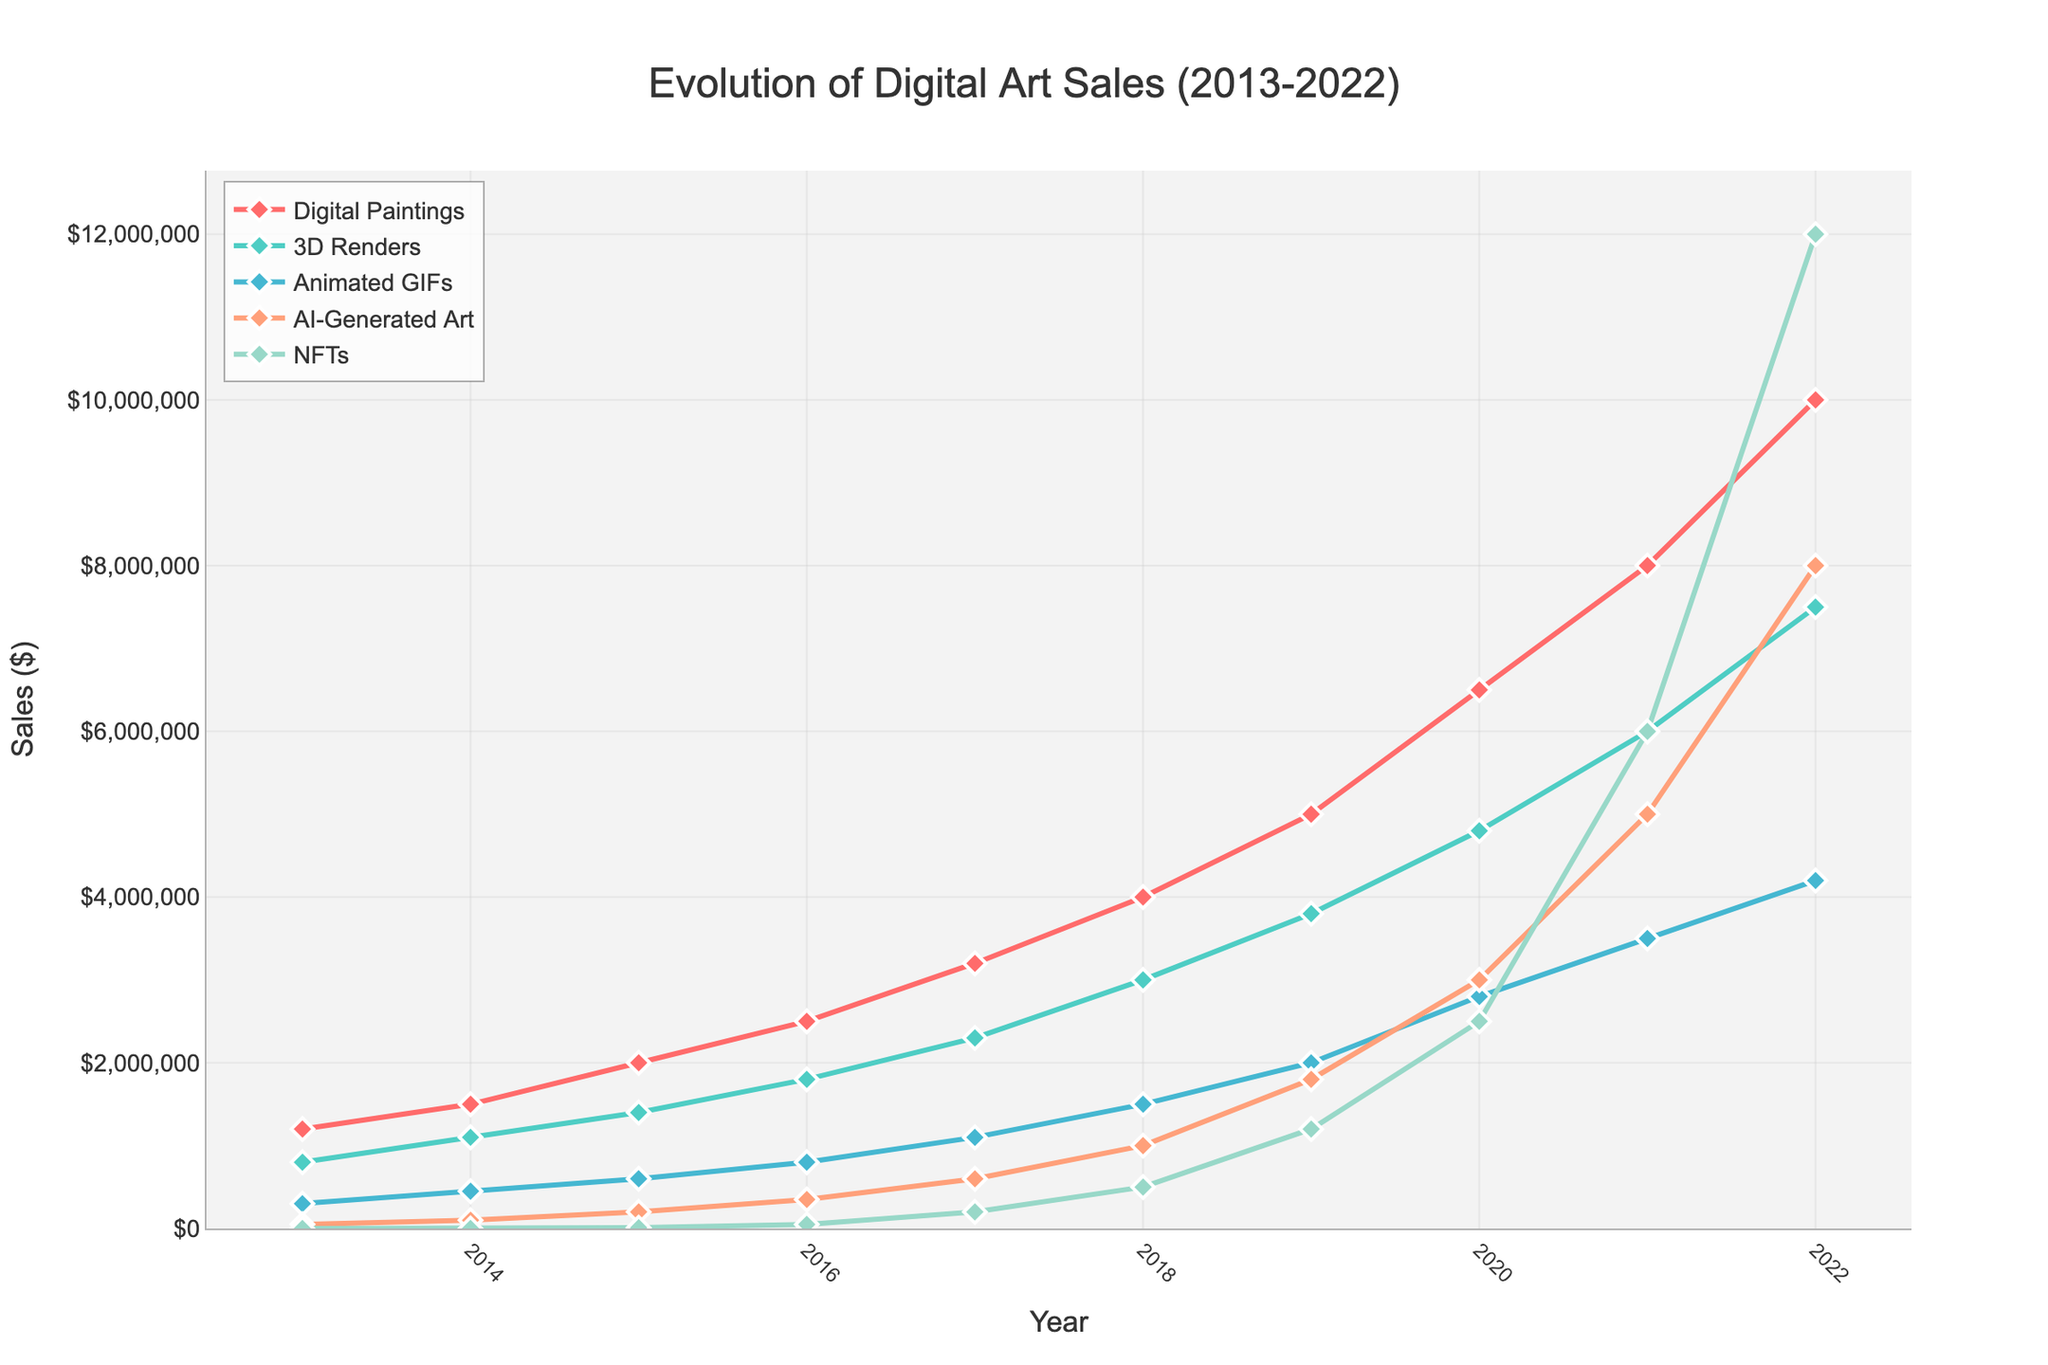What year did NFTs surpass all other mediums in sales? In 2021, the NFTs' sales surpassed all other mediums reaching higher sales figures than others. By 2021, NFTs achieved $6,000,000, while the next highest, AI-Generated Art, reached $5,000,000.
Answer: 2021 Which medium had the smallest sales increase from 2013 to 2022? To determine the smallest sales increase, subtract the 2013 value from the 2022 value for each medium. Digital Paintings: $10,000,000 - $1,200,000 = $8,800,000; 3D Renders: $7,500,000 - $800,000 = $6,700,000; Animated GIFs: $4,200,000 - $300,000 = $3,900,000; AI-Generated Art: $8,000,000 - $50,000 = $7,950,000; NFTs: $12,000,000 - $0 = $12,000,000. Animated GIFs had the smallest sales increase of $3,900,000.
Answer: Animated GIFs By what percentage did AI-Generated Art sales grow from 2016 to 2022? Calculate the percentage growth by using the formula [(Sales in 2022 - Sales in 2016) / Sales in 2016] * 100. For AI-Generated Art: [(8,000,000 - 350,000) / 350,000] * 100 = 2171.43%.
Answer: 2171.43% In 2020, which two mediums had the closest sales figures and what was the difference? In 2020, 3D Renders and Animated GIFs had sales of $4,800,000 and $2,800,000 respectively. Other combinations have larger differences; the closest combination is 3D Renders and Animated GIFs with a difference of $4,800,000 - $2,800,000 = $2,000,000.
Answer: 3D Renders and Animated GIFs; $2,000,000 How many years did it take for Digital Paintings to reach $5,000,000 in sales? Digital Paintings reached $5,000,000 in sales in 2019. Starting in 2013, it took 2019 - 2013 = 6 years.
Answer: 6 years Compare the growth rates of Digital Paintings and 3D Renders between 2013 and 2022. Which grew faster? Calculate the growth rate using the formula (Sales in 2022 / Sales in 2013). For Digital Paintings: $10,000,000 / $1,200,000 ≈ 8.33. For 3D Renders: $7,500,000 / $800,000 ≈ 9.375. 3D Renders grew faster.
Answer: 3D Renders Which medium experienced the largest single-year increase in sales during the decade? To identify the largest single-year increase, observe the data for each year. NFTs saw the largest jump between 2021 and 2022, increasing from $6,000,000 to $12,000,000, which is an increase of $6,000,000.
Answer: NFTs 